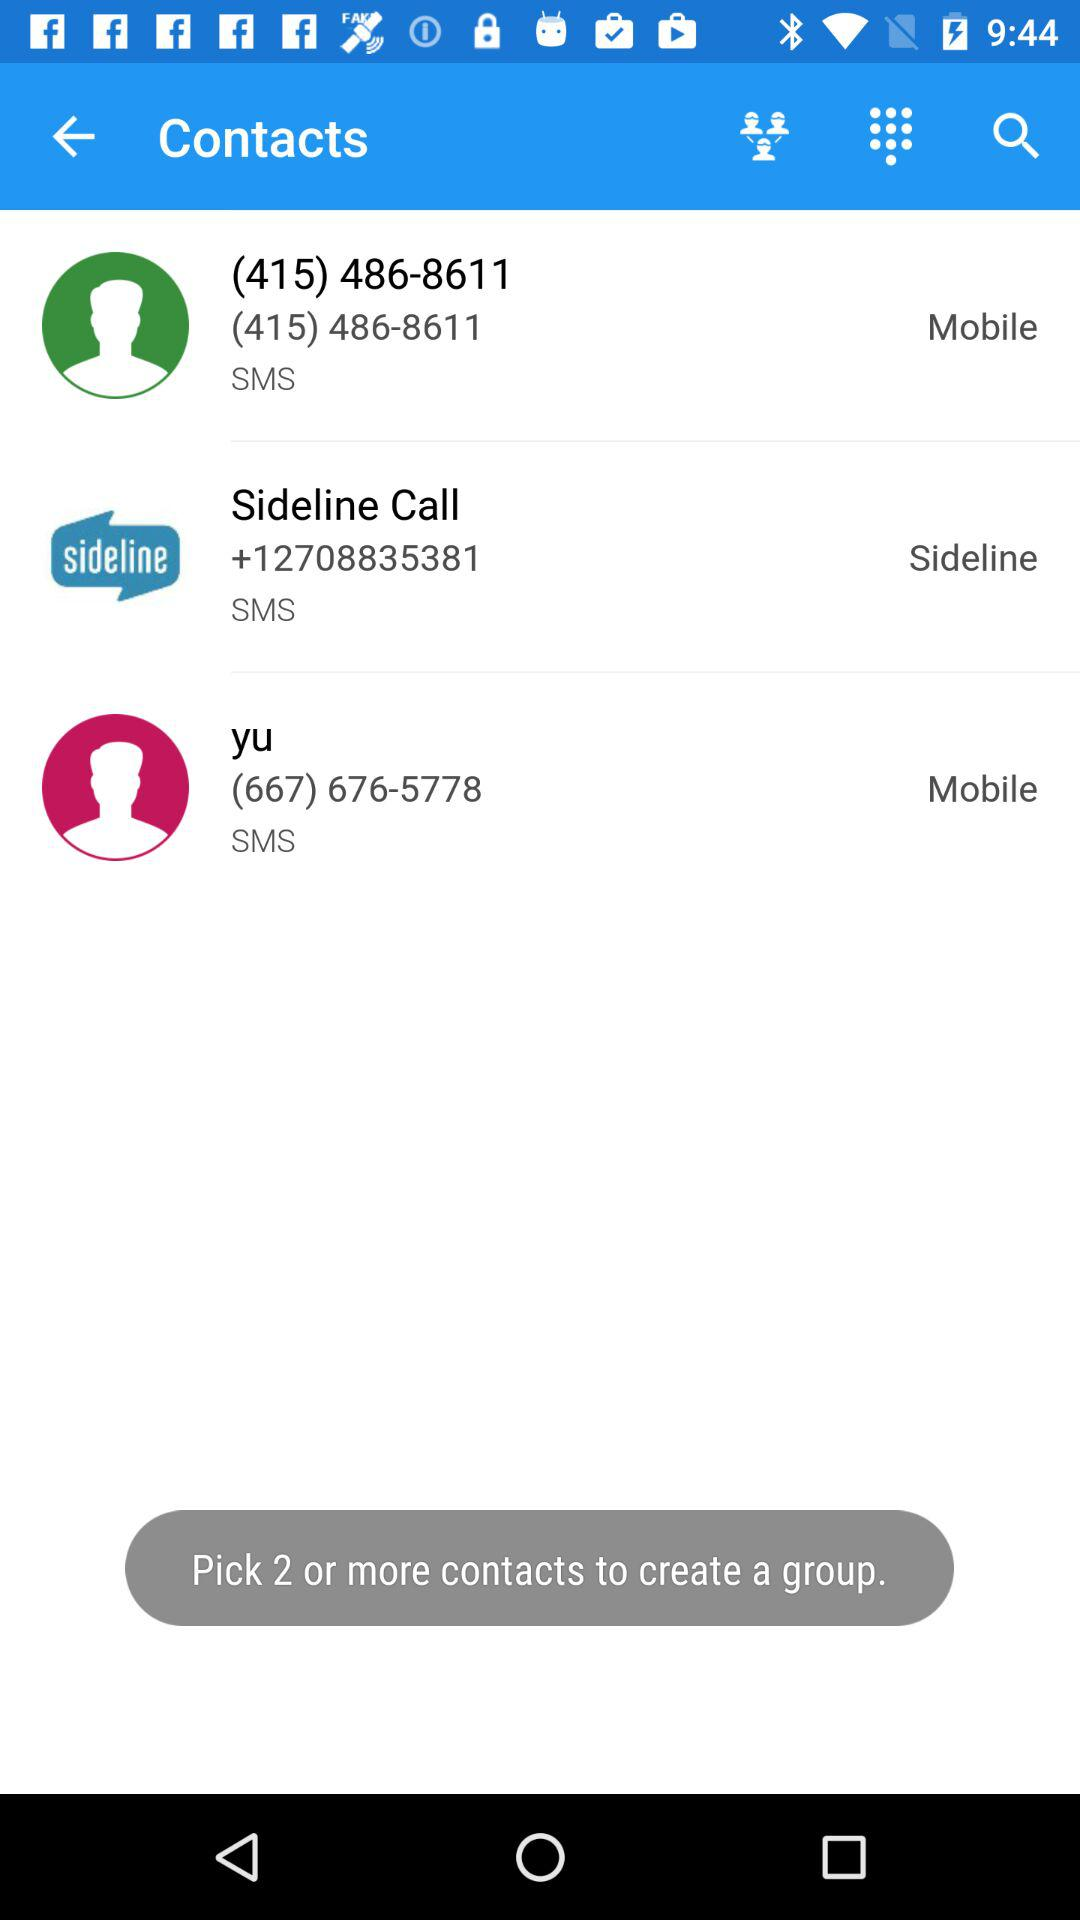What is the contact number for "Sideline Call"? The contact number is +12708835381. 